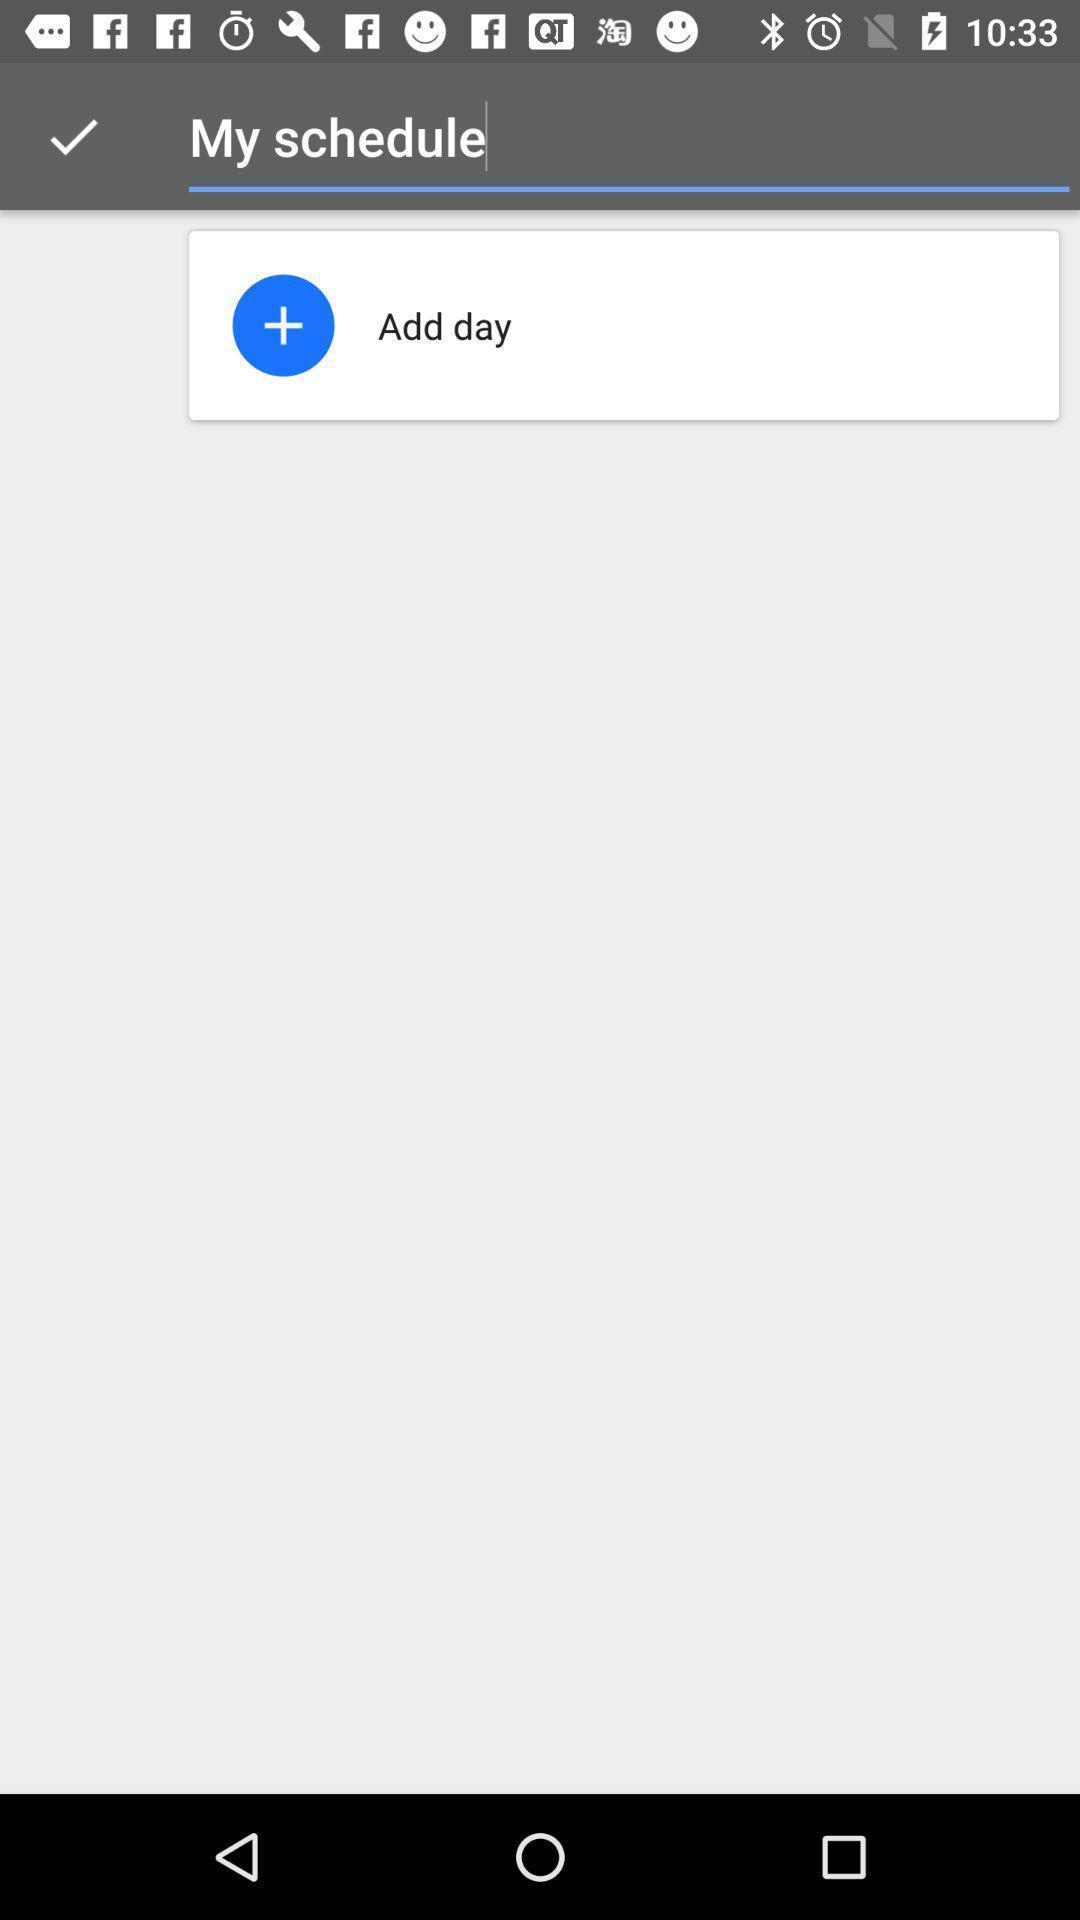Tell me what you see in this picture. Screen showing the empty page in schedules. 